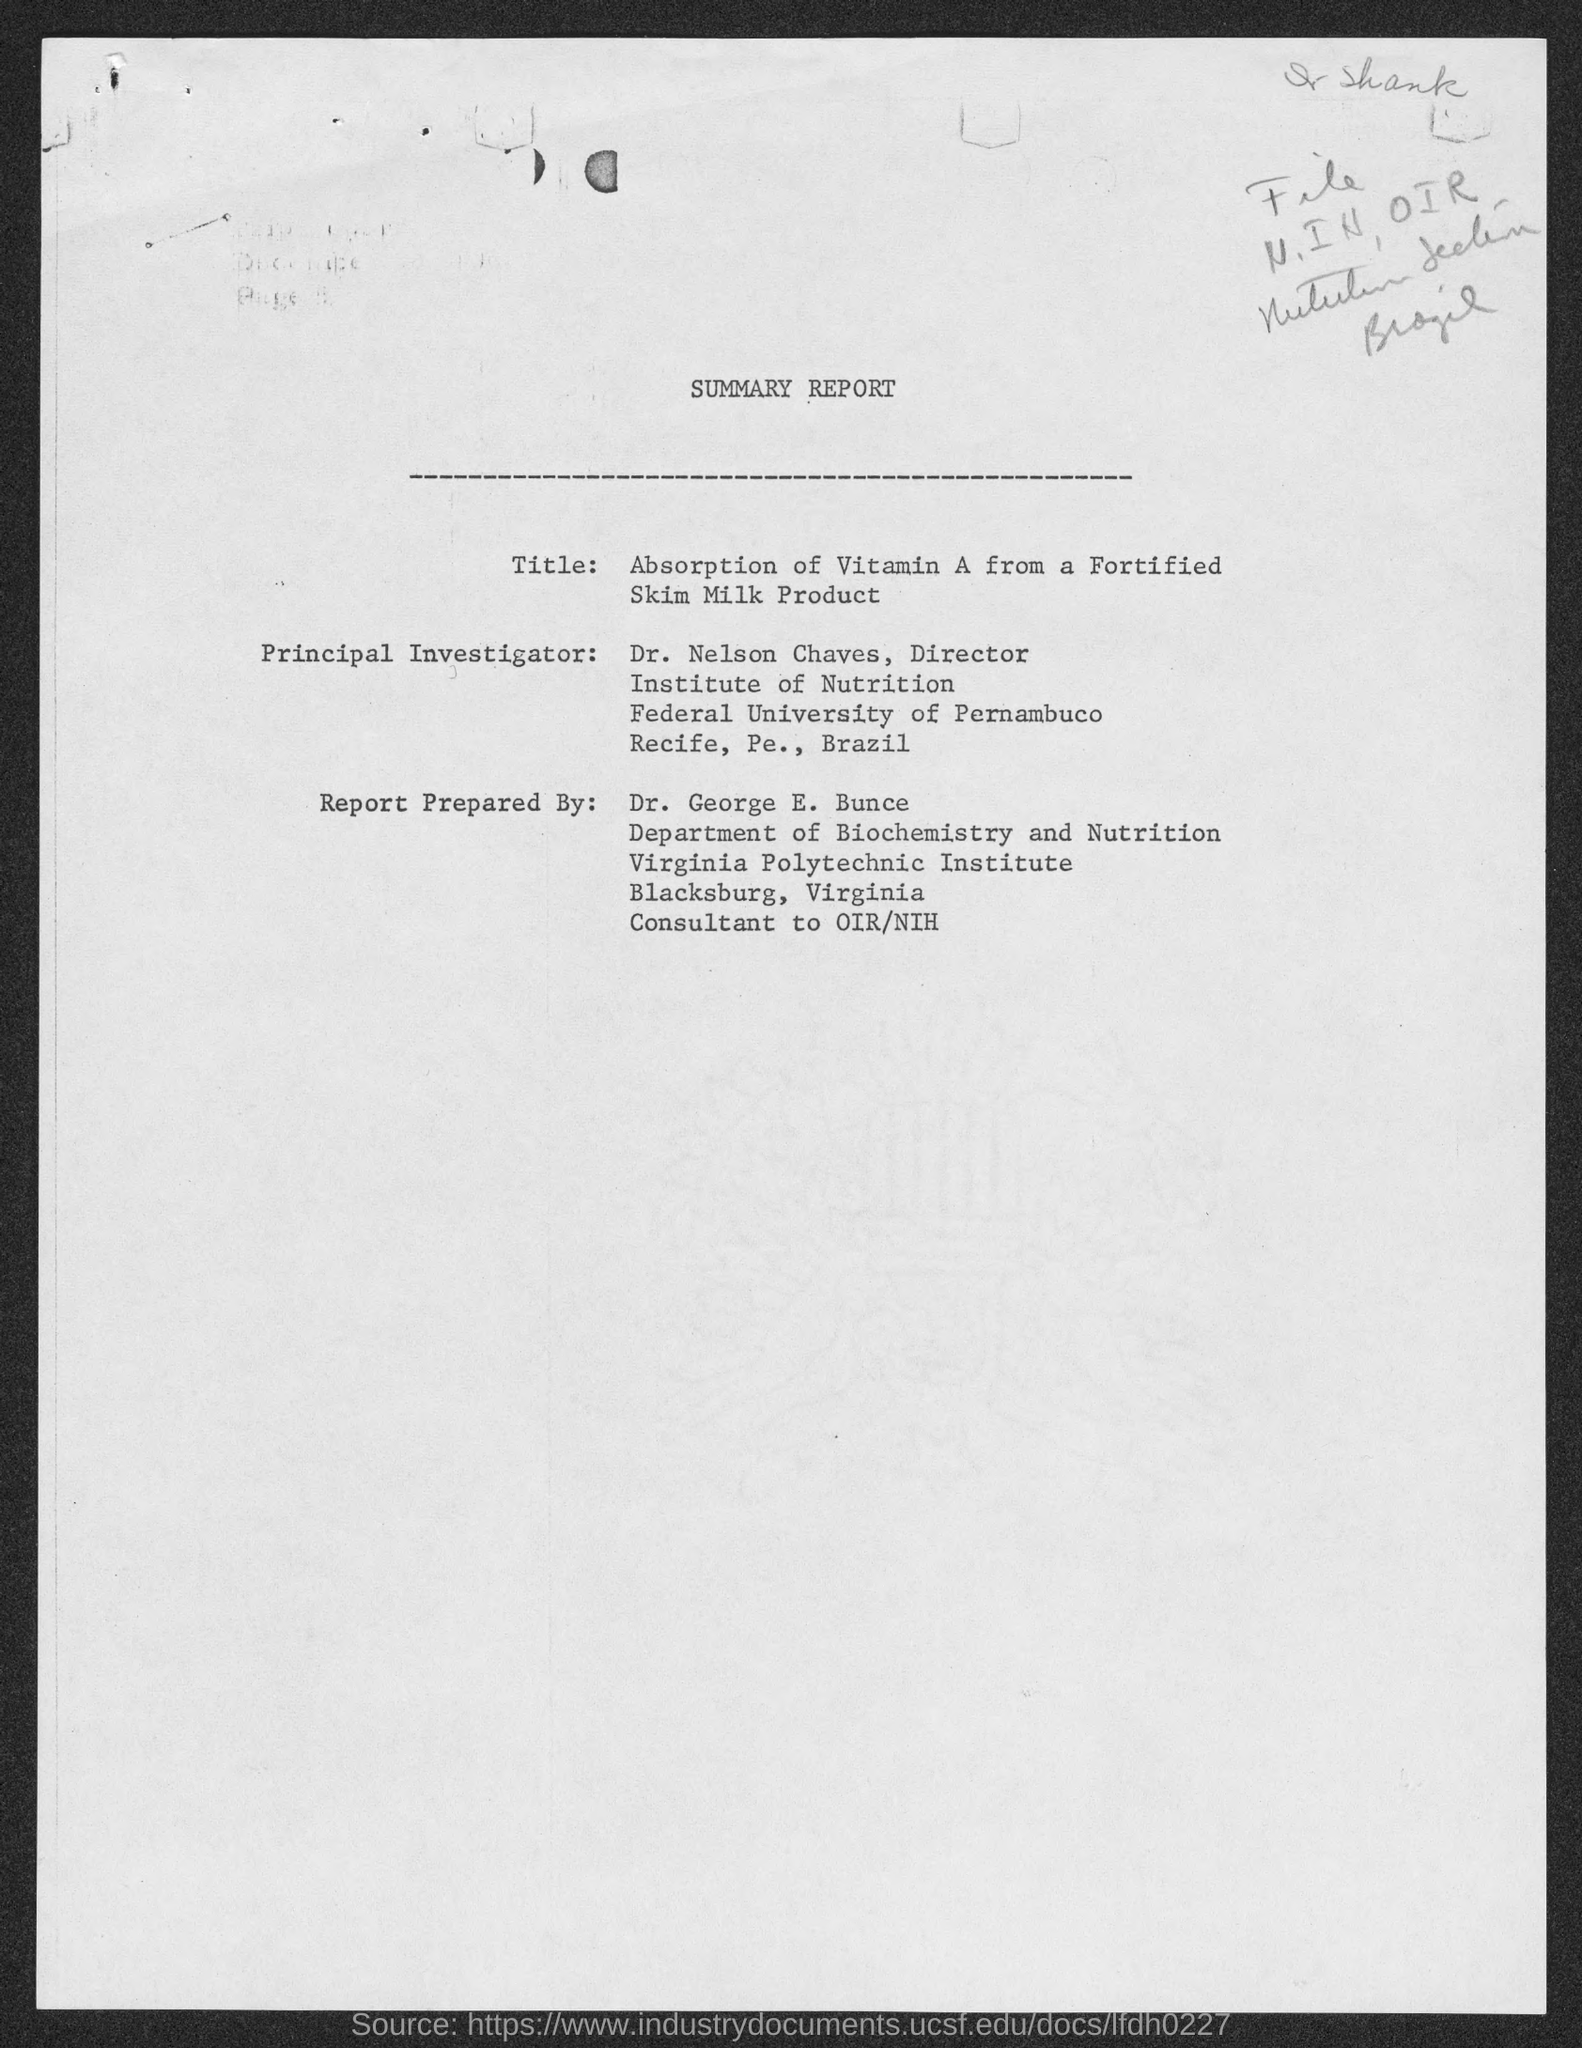Give some essential details in this illustration. The document, titled "summary report," was prepared by Dr. George E. Bunce. Dr. George E. Bunce belongs to the Virginia Polytechnic Institute. Dr. Nelson Chaves is a member of the Federal University of Pernambuco. Dr. Nelson Chaves is the principal investigator. Dr. Nelson Chaves holds the position of Director. 